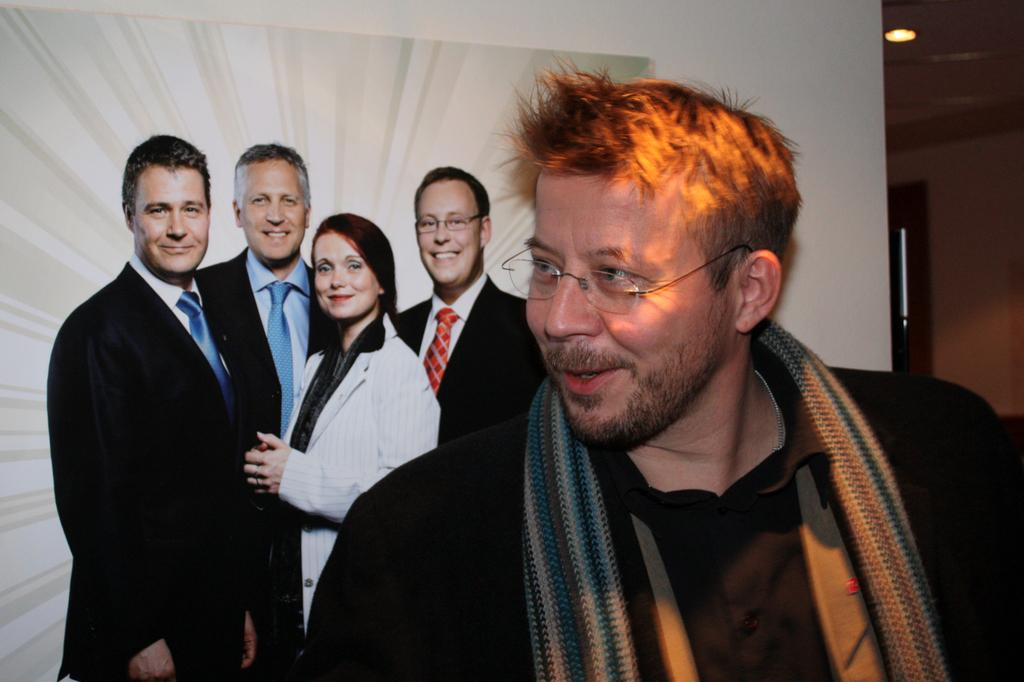Who is present in the image? There is a person in the image. What can be observed about the person's appearance? The person is wearing glasses and a scarf. What is visible in the background of the image? There is a board, people on the board, a light, and a wall in the background of the image. What type of education does the lawyer provide on the line in the image? There is no lawyer or line present in the image, so it is not possible to answer that question. 